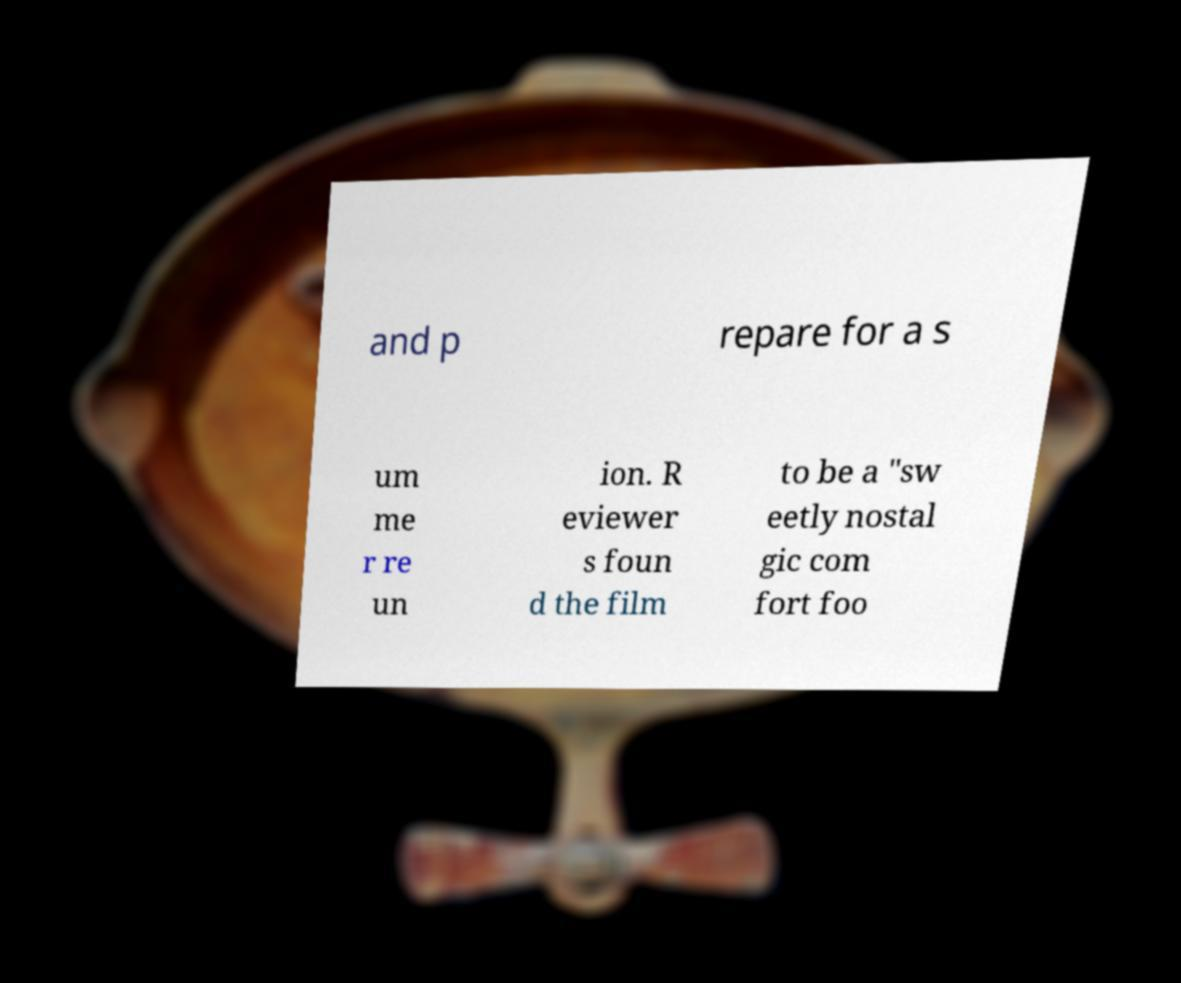Can you accurately transcribe the text from the provided image for me? and p repare for a s um me r re un ion. R eviewer s foun d the film to be a "sw eetly nostal gic com fort foo 